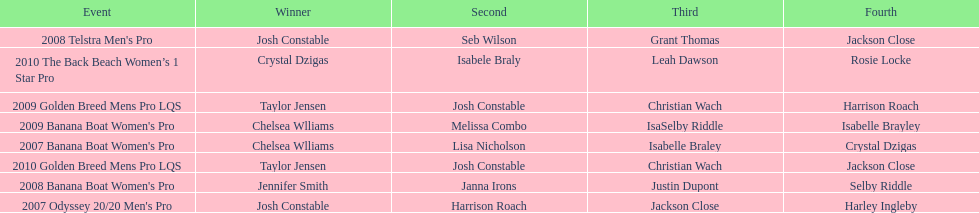How many times was josh constable second? 2. 